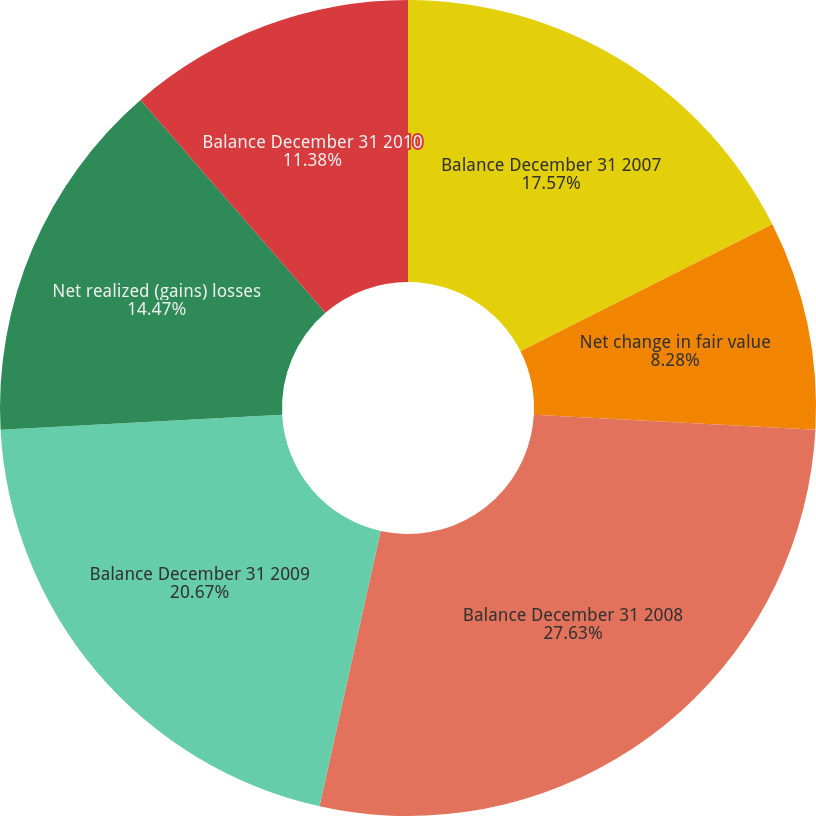<chart> <loc_0><loc_0><loc_500><loc_500><pie_chart><fcel>Balance December 31 2007<fcel>Net change in fair value<fcel>Balance December 31 2008<fcel>Balance December 31 2009<fcel>Net realized (gains) losses<fcel>Balance December 31 2010<nl><fcel>17.57%<fcel>8.28%<fcel>27.63%<fcel>20.67%<fcel>14.47%<fcel>11.38%<nl></chart> 